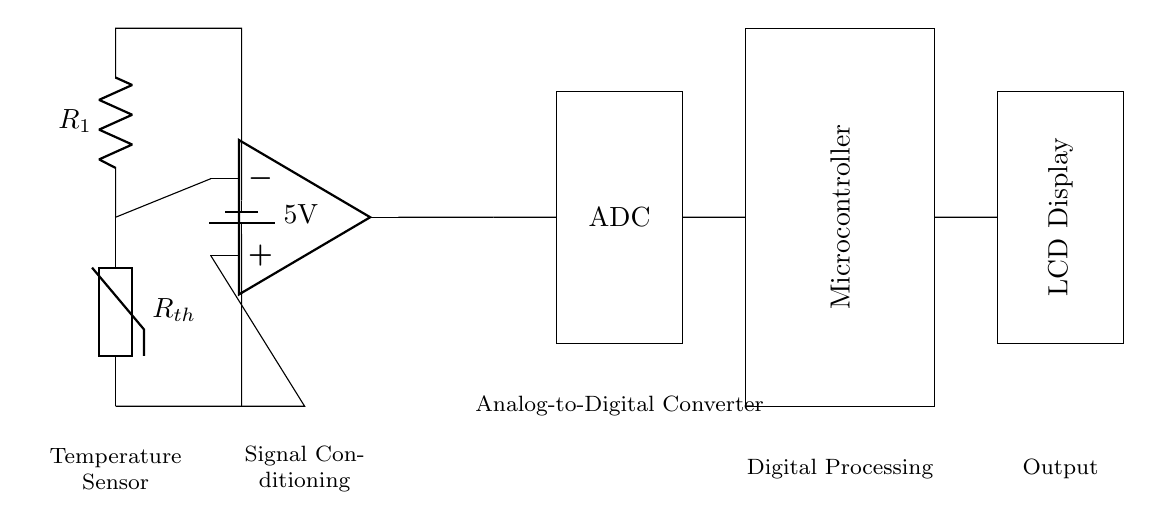What component is used as a temperature sensor? The circuit diagram shows a thermistor labeled as Rth, which is specifically designed to measure temperature.
Answer: Thermistor What voltage is supplied to the circuit? The circuit indicates a battery supplying a voltage of 5V, as labeled in the diagram.
Answer: 5V How many main functional blocks are present in the circuit? There are four main functional blocks: Temperature Sensor, Signal Conditioning, Analog-to-Digital Converter, and Digital Processing.
Answer: Four What role does the operational amplifier play in this circuit? The operational amplifier is used for signal conditioning, amplifying the sensor output signal to make it suitable for further processing.
Answer: Signal Conditioning What type of display is used for output? The output is shown to be an LCD display, as labeled in the diagram, which presents the measured temperature.
Answer: LCD Display How does the temperature sensor connect to the operational amplifier? The temperature sensor connects directly to the inverting input of the operational amplifier, indicating that it provides the raw temperature signal for amplification.
Answer: Directly Which component converts the analog signal to a digital format? The Analog-to-Digital Converter (ADC) is specifically responsible for converting the analog signal coming from the operational amplifier into a digital format for processing.
Answer: ADC 